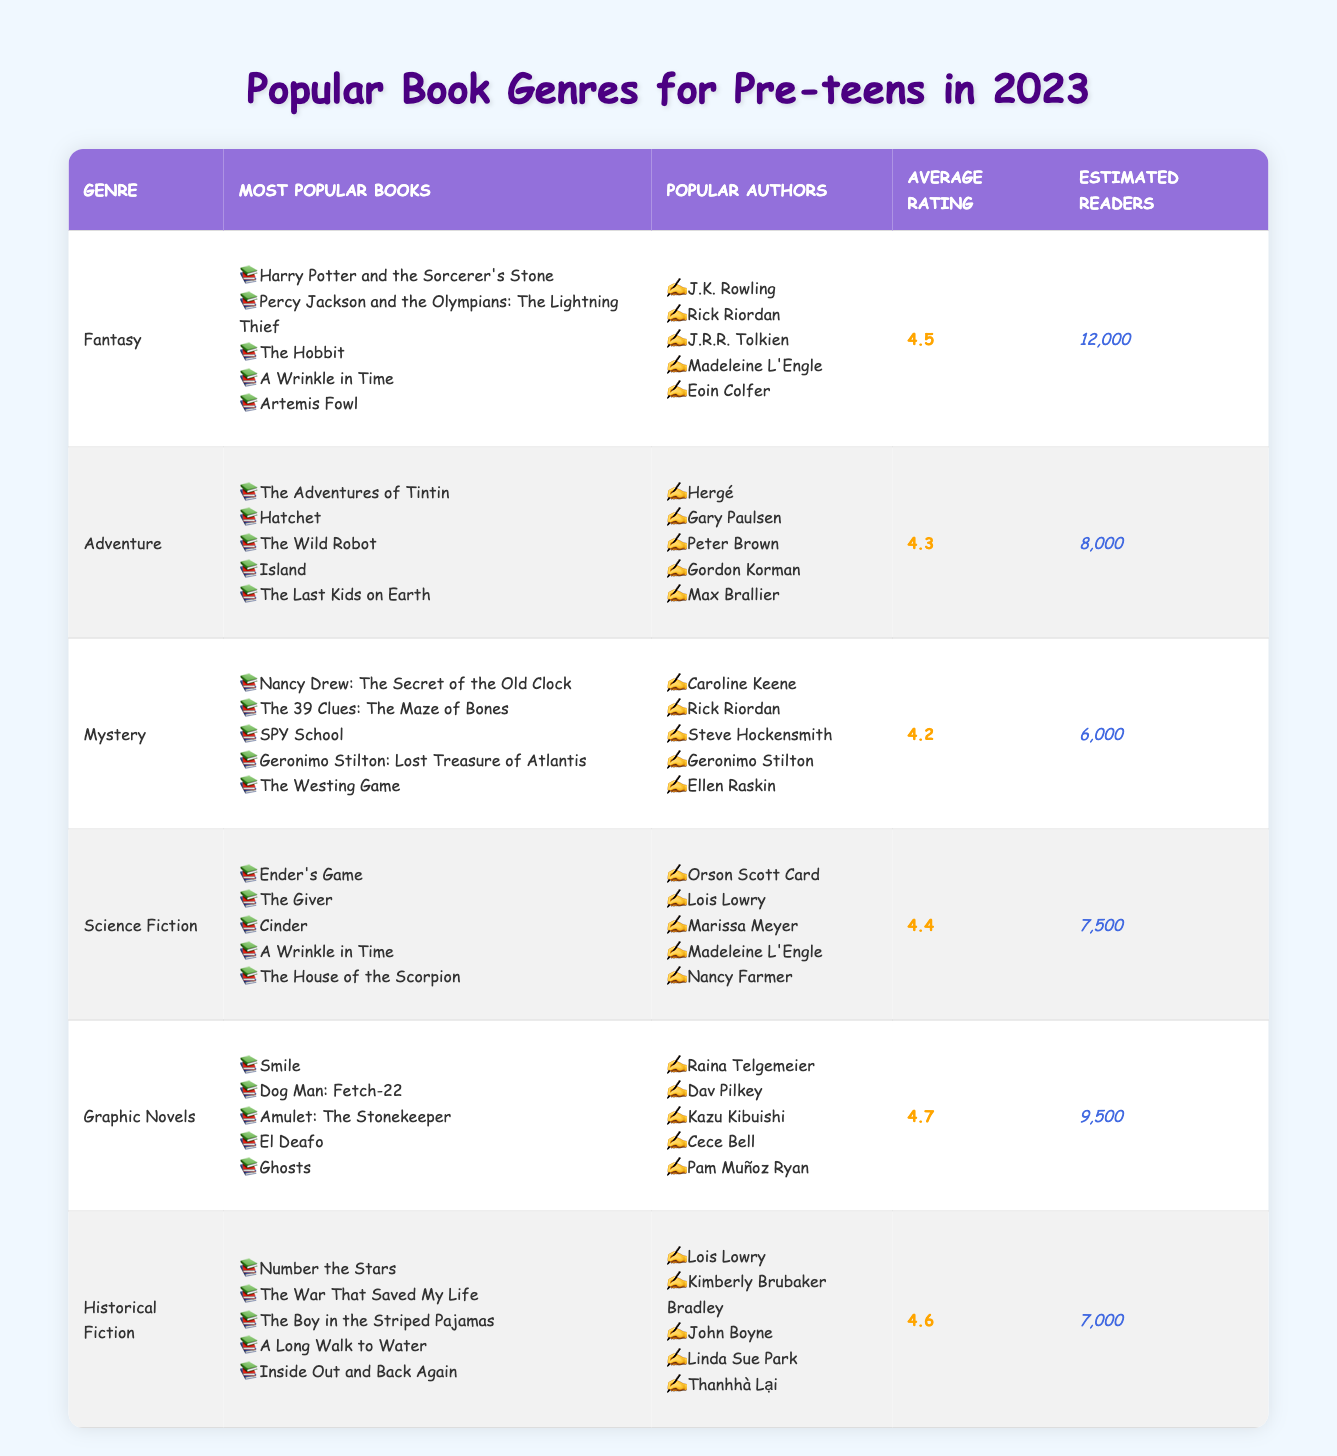What's the most popular book genre among pre-teens in 2023? The genre with the highest estimated readers, which is 12,000, is Fantasy.
Answer: Fantasy Which genre has the highest average rating? The average ratings are: Fantasy (4.5), Adventure (4.3), Mystery (4.2), Science Fiction (4.4), Graphic Novels (4.7), Historical Fiction (4.6). The highest is Graphic Novels with a rating of 4.7.
Answer: Graphic Novels How many estimated readers read Science Fiction? The table states the estimated readers for Science Fiction is 7,500.
Answer: 7,500 Which genre has the lowest estimated readers and what is that number? The lowest estimated readers are for Historical Fiction with 7,000 readers.
Answer: Historical Fiction; 7,000 How many more estimated readers does Fantasy have compared to Adventure? Fantasy has 12,000 readers, and Adventure has 8,000. The difference is 12,000 - 8,000 = 4,000.
Answer: 4,000 Which author appears most frequently across the genres listed? Upon reviewing the authors, Rick Riordan appears in both Fantasy and Mystery genres, making him the most frequently appearing author.
Answer: Rick Riordan What is the average rating of the Adventure genre? The Adventure genre has an average rating of 4.3 as noted in the table.
Answer: 4.3 Is there a genre with an average rating below 4.0? The lowest average rating is 4.2 for Mystery, so no genre is below 4.0.
Answer: No If you combined the estimated readers of Adventure and Mystery, how many total readers would that be? Adventure has 8,000 readers and Mystery has 6,000. The total is 8,000 + 6,000 = 14,000.
Answer: 14,000 How many different authors are mentioned in the table? By counting unique authors listed under each genre, we find there are 22 distinct authors.
Answer: 22 authors 